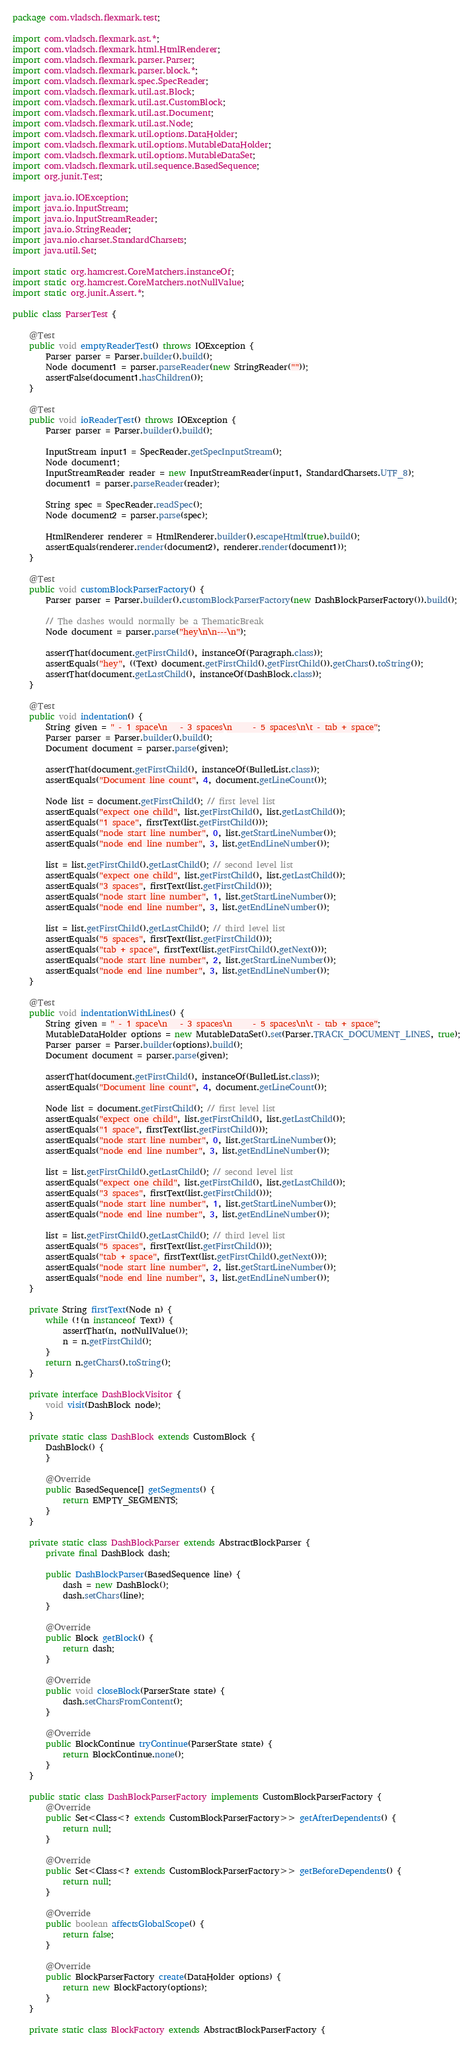<code> <loc_0><loc_0><loc_500><loc_500><_Java_>package com.vladsch.flexmark.test;

import com.vladsch.flexmark.ast.*;
import com.vladsch.flexmark.html.HtmlRenderer;
import com.vladsch.flexmark.parser.Parser;
import com.vladsch.flexmark.parser.block.*;
import com.vladsch.flexmark.spec.SpecReader;
import com.vladsch.flexmark.util.ast.Block;
import com.vladsch.flexmark.util.ast.CustomBlock;
import com.vladsch.flexmark.util.ast.Document;
import com.vladsch.flexmark.util.ast.Node;
import com.vladsch.flexmark.util.options.DataHolder;
import com.vladsch.flexmark.util.options.MutableDataHolder;
import com.vladsch.flexmark.util.options.MutableDataSet;
import com.vladsch.flexmark.util.sequence.BasedSequence;
import org.junit.Test;

import java.io.IOException;
import java.io.InputStream;
import java.io.InputStreamReader;
import java.io.StringReader;
import java.nio.charset.StandardCharsets;
import java.util.Set;

import static org.hamcrest.CoreMatchers.instanceOf;
import static org.hamcrest.CoreMatchers.notNullValue;
import static org.junit.Assert.*;

public class ParserTest {

    @Test
    public void emptyReaderTest() throws IOException {
        Parser parser = Parser.builder().build();
        Node document1 = parser.parseReader(new StringReader(""));
        assertFalse(document1.hasChildren());
    }

    @Test
    public void ioReaderTest() throws IOException {
        Parser parser = Parser.builder().build();

        InputStream input1 = SpecReader.getSpecInputStream();
        Node document1;
        InputStreamReader reader = new InputStreamReader(input1, StandardCharsets.UTF_8);
        document1 = parser.parseReader(reader);

        String spec = SpecReader.readSpec();
        Node document2 = parser.parse(spec);

        HtmlRenderer renderer = HtmlRenderer.builder().escapeHtml(true).build();
        assertEquals(renderer.render(document2), renderer.render(document1));
    }

    @Test
    public void customBlockParserFactory() {
        Parser parser = Parser.builder().customBlockParserFactory(new DashBlockParserFactory()).build();

        // The dashes would normally be a ThematicBreak
        Node document = parser.parse("hey\n\n---\n");

        assertThat(document.getFirstChild(), instanceOf(Paragraph.class));
        assertEquals("hey", ((Text) document.getFirstChild().getFirstChild()).getChars().toString());
        assertThat(document.getLastChild(), instanceOf(DashBlock.class));
    }

    @Test
    public void indentation() {
        String given = " - 1 space\n   - 3 spaces\n     - 5 spaces\n\t - tab + space";
        Parser parser = Parser.builder().build();
        Document document = parser.parse(given);

        assertThat(document.getFirstChild(), instanceOf(BulletList.class));
        assertEquals("Document line count", 4, document.getLineCount());

        Node list = document.getFirstChild(); // first level list
        assertEquals("expect one child", list.getFirstChild(), list.getLastChild());
        assertEquals("1 space", firstText(list.getFirstChild()));
        assertEquals("node start line number", 0, list.getStartLineNumber());
        assertEquals("node end line number", 3, list.getEndLineNumber());

        list = list.getFirstChild().getLastChild(); // second level list
        assertEquals("expect one child", list.getFirstChild(), list.getLastChild());
        assertEquals("3 spaces", firstText(list.getFirstChild()));
        assertEquals("node start line number", 1, list.getStartLineNumber());
        assertEquals("node end line number", 3, list.getEndLineNumber());

        list = list.getFirstChild().getLastChild(); // third level list
        assertEquals("5 spaces", firstText(list.getFirstChild()));
        assertEquals("tab + space", firstText(list.getFirstChild().getNext()));
        assertEquals("node start line number", 2, list.getStartLineNumber());
        assertEquals("node end line number", 3, list.getEndLineNumber());
    }

    @Test
    public void indentationWithLines() {
        String given = " - 1 space\n   - 3 spaces\n     - 5 spaces\n\t - tab + space";
        MutableDataHolder options = new MutableDataSet().set(Parser.TRACK_DOCUMENT_LINES, true);
        Parser parser = Parser.builder(options).build();
        Document document = parser.parse(given);

        assertThat(document.getFirstChild(), instanceOf(BulletList.class));
        assertEquals("Document line count", 4, document.getLineCount());

        Node list = document.getFirstChild(); // first level list
        assertEquals("expect one child", list.getFirstChild(), list.getLastChild());
        assertEquals("1 space", firstText(list.getFirstChild()));
        assertEquals("node start line number", 0, list.getStartLineNumber());
        assertEquals("node end line number", 3, list.getEndLineNumber());

        list = list.getFirstChild().getLastChild(); // second level list
        assertEquals("expect one child", list.getFirstChild(), list.getLastChild());
        assertEquals("3 spaces", firstText(list.getFirstChild()));
        assertEquals("node start line number", 1, list.getStartLineNumber());
        assertEquals("node end line number", 3, list.getEndLineNumber());

        list = list.getFirstChild().getLastChild(); // third level list
        assertEquals("5 spaces", firstText(list.getFirstChild()));
        assertEquals("tab + space", firstText(list.getFirstChild().getNext()));
        assertEquals("node start line number", 2, list.getStartLineNumber());
        assertEquals("node end line number", 3, list.getEndLineNumber());
    }

    private String firstText(Node n) {
        while (!(n instanceof Text)) {
            assertThat(n, notNullValue());
            n = n.getFirstChild();
        }
        return n.getChars().toString();
    }

    private interface DashBlockVisitor {
        void visit(DashBlock node);
    }

    private static class DashBlock extends CustomBlock {
        DashBlock() {
        }

        @Override
        public BasedSequence[] getSegments() {
            return EMPTY_SEGMENTS;
        }
    }

    private static class DashBlockParser extends AbstractBlockParser {
        private final DashBlock dash;

        public DashBlockParser(BasedSequence line) {
            dash = new DashBlock();
            dash.setChars(line);
        }

        @Override
        public Block getBlock() {
            return dash;
        }

        @Override
        public void closeBlock(ParserState state) {
            dash.setCharsFromContent();
        }

        @Override
        public BlockContinue tryContinue(ParserState state) {
            return BlockContinue.none();
        }
    }

    public static class DashBlockParserFactory implements CustomBlockParserFactory {
        @Override
        public Set<Class<? extends CustomBlockParserFactory>> getAfterDependents() {
            return null;
        }

        @Override
        public Set<Class<? extends CustomBlockParserFactory>> getBeforeDependents() {
            return null;
        }

        @Override
        public boolean affectsGlobalScope() {
            return false;
        }

        @Override
        public BlockParserFactory create(DataHolder options) {
            return new BlockFactory(options);
        }
    }

    private static class BlockFactory extends AbstractBlockParserFactory {</code> 